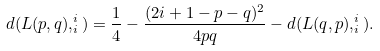Convert formula to latex. <formula><loc_0><loc_0><loc_500><loc_500>d ( L ( p , q ) , ^ { i } _ { i } ) = \frac { 1 } { 4 } - \frac { ( 2 i + 1 - p - q ) ^ { 2 } } { 4 p q } - d ( L ( q , p ) , ^ { i } _ { i } ) .</formula> 